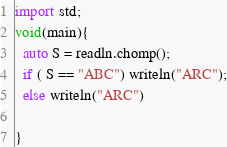Convert code to text. <code><loc_0><loc_0><loc_500><loc_500><_D_>import std;
void(main){
  auto S = readln.chomp();
  if ( S == "ABC") writeln("ARC");
  else writeln("ARC")
  
}
</code> 